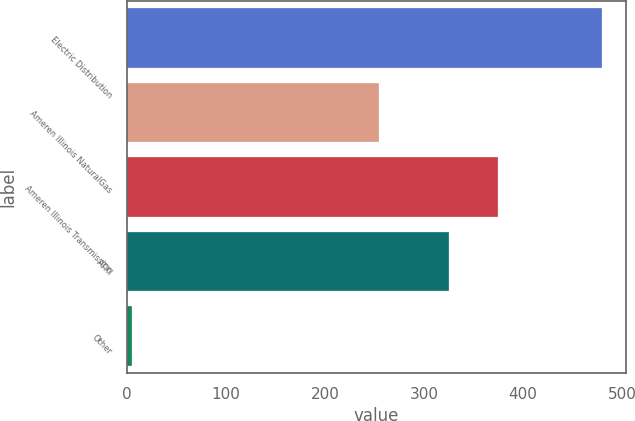Convert chart to OTSL. <chart><loc_0><loc_0><loc_500><loc_500><bar_chart><fcel>Electric Distribution<fcel>Ameren Illinois NaturalGas<fcel>Ameren Illinois Transmission<fcel>ATXI<fcel>Other<nl><fcel>480<fcel>255<fcel>375<fcel>325<fcel>5<nl></chart> 